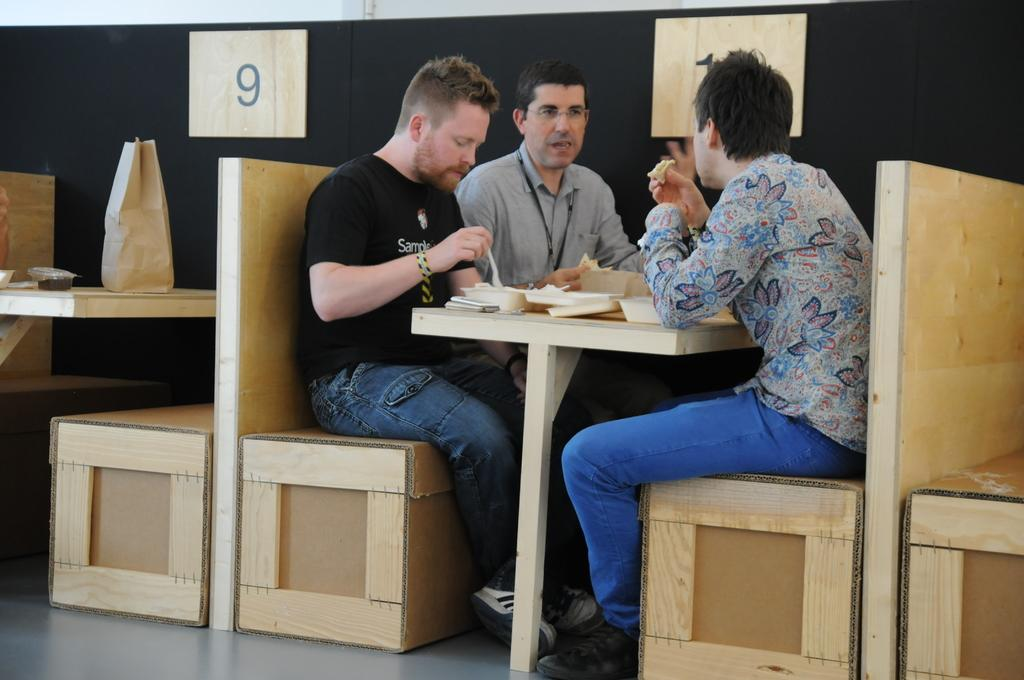How many people are in the image? There are three men in the image. What are the men doing in the image? The men are seated on either side of a table and are having food. Can you describe the setting of the image? The setting appears to be in a hotel. What type of clover is growing on the table in the image? There is no clover present in the image; the table is set for a meal with food and utensils. 